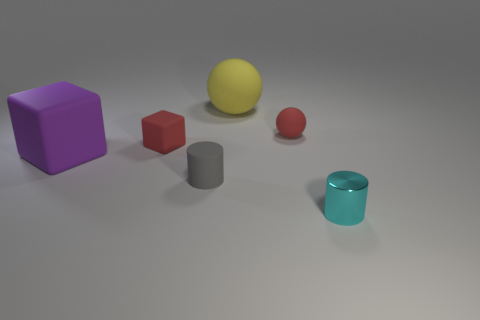There is another tiny thing that is the same shape as the small gray rubber thing; what material is it?
Provide a succinct answer. Metal. There is a thing that is on the left side of the tiny object left of the small cylinder that is behind the small cyan shiny cylinder; what size is it?
Make the answer very short. Large. Is the purple object the same size as the gray object?
Your answer should be compact. No. The cylinder right of the cylinder on the left side of the small shiny cylinder is made of what material?
Your answer should be compact. Metal. There is a large matte thing on the right side of the gray object; is it the same shape as the red rubber thing on the right side of the large yellow rubber thing?
Your answer should be very brief. Yes. Are there an equal number of small matte objects behind the gray object and large things?
Offer a terse response. Yes. Is there a red rubber thing that is to the right of the cylinder behind the cyan object?
Make the answer very short. Yes. Are there any other things that are the same color as the big rubber block?
Ensure brevity in your answer.  No. Is the material of the red thing on the left side of the tiny red sphere the same as the big ball?
Offer a terse response. Yes. Are there the same number of red rubber balls that are right of the small red matte sphere and tiny rubber cylinders that are in front of the yellow ball?
Provide a short and direct response. No. 